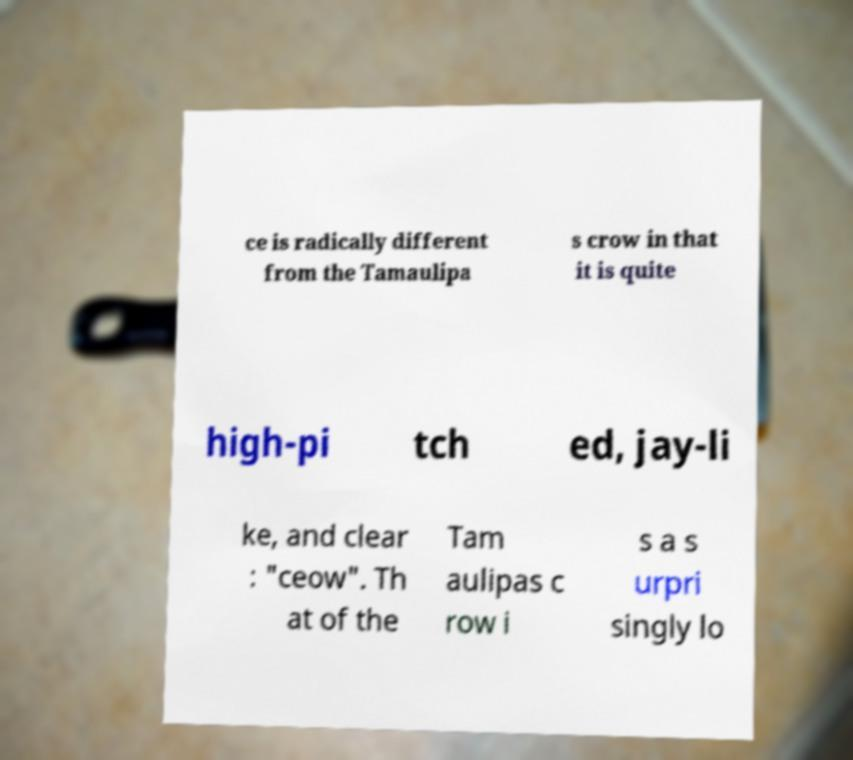Please identify and transcribe the text found in this image. ce is radically different from the Tamaulipa s crow in that it is quite high-pi tch ed, jay-li ke, and clear : "ceow". Th at of the Tam aulipas c row i s a s urpri singly lo 